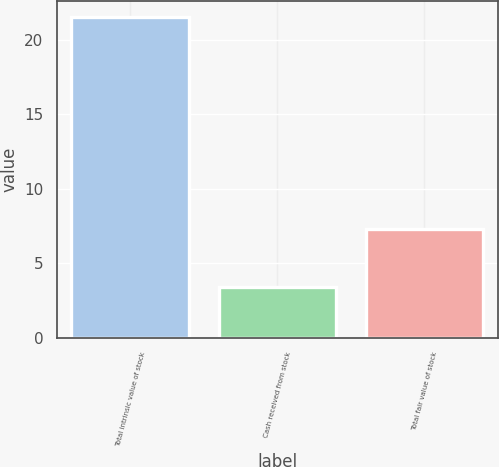Convert chart. <chart><loc_0><loc_0><loc_500><loc_500><bar_chart><fcel>Total intrinsic value of stock<fcel>Cash received from stock<fcel>Total fair value of stock<nl><fcel>21.5<fcel>3.4<fcel>7.3<nl></chart> 